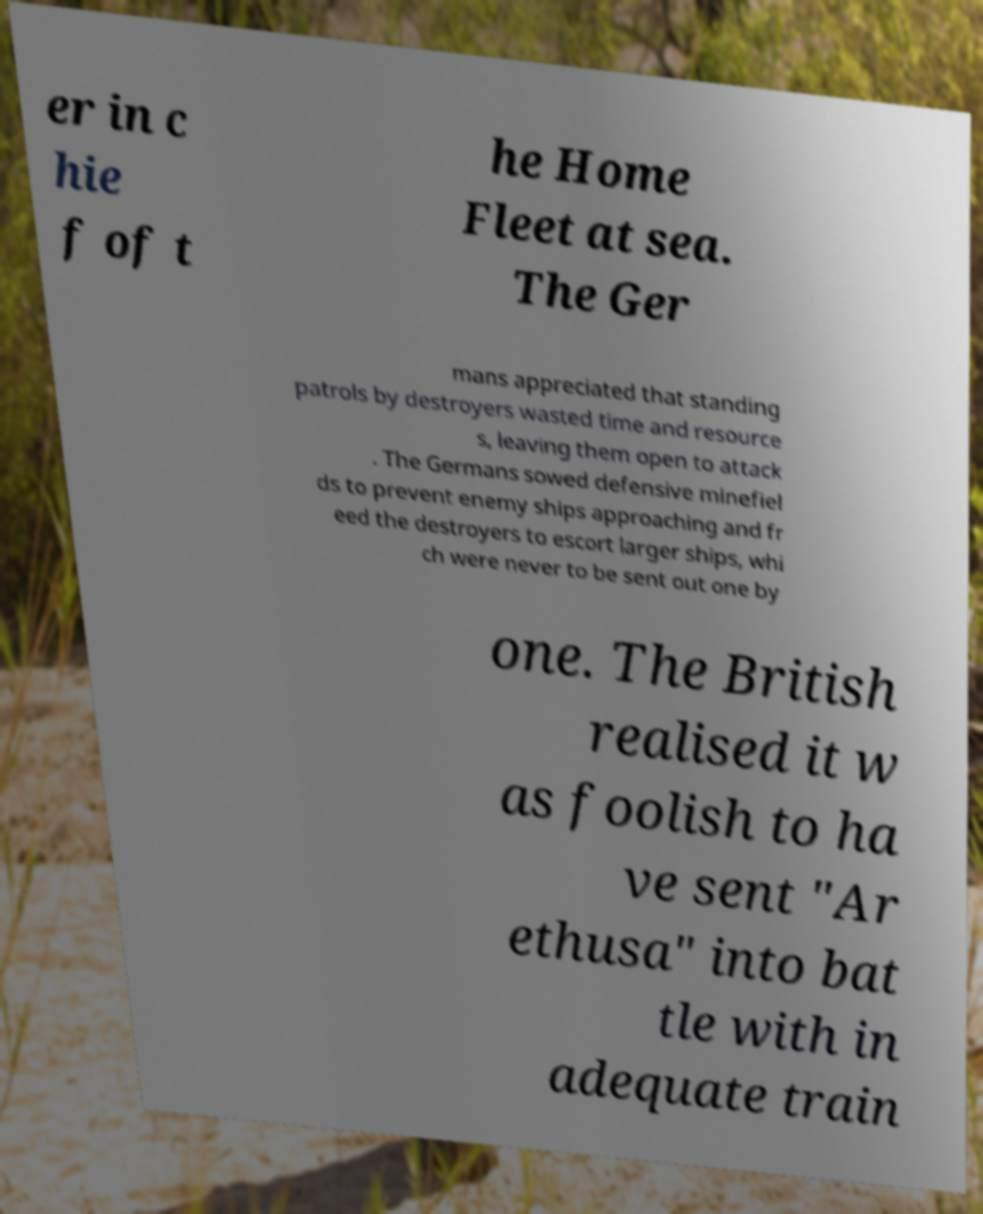What messages or text are displayed in this image? I need them in a readable, typed format. er in c hie f of t he Home Fleet at sea. The Ger mans appreciated that standing patrols by destroyers wasted time and resource s, leaving them open to attack . The Germans sowed defensive minefiel ds to prevent enemy ships approaching and fr eed the destroyers to escort larger ships, whi ch were never to be sent out one by one. The British realised it w as foolish to ha ve sent "Ar ethusa" into bat tle with in adequate train 